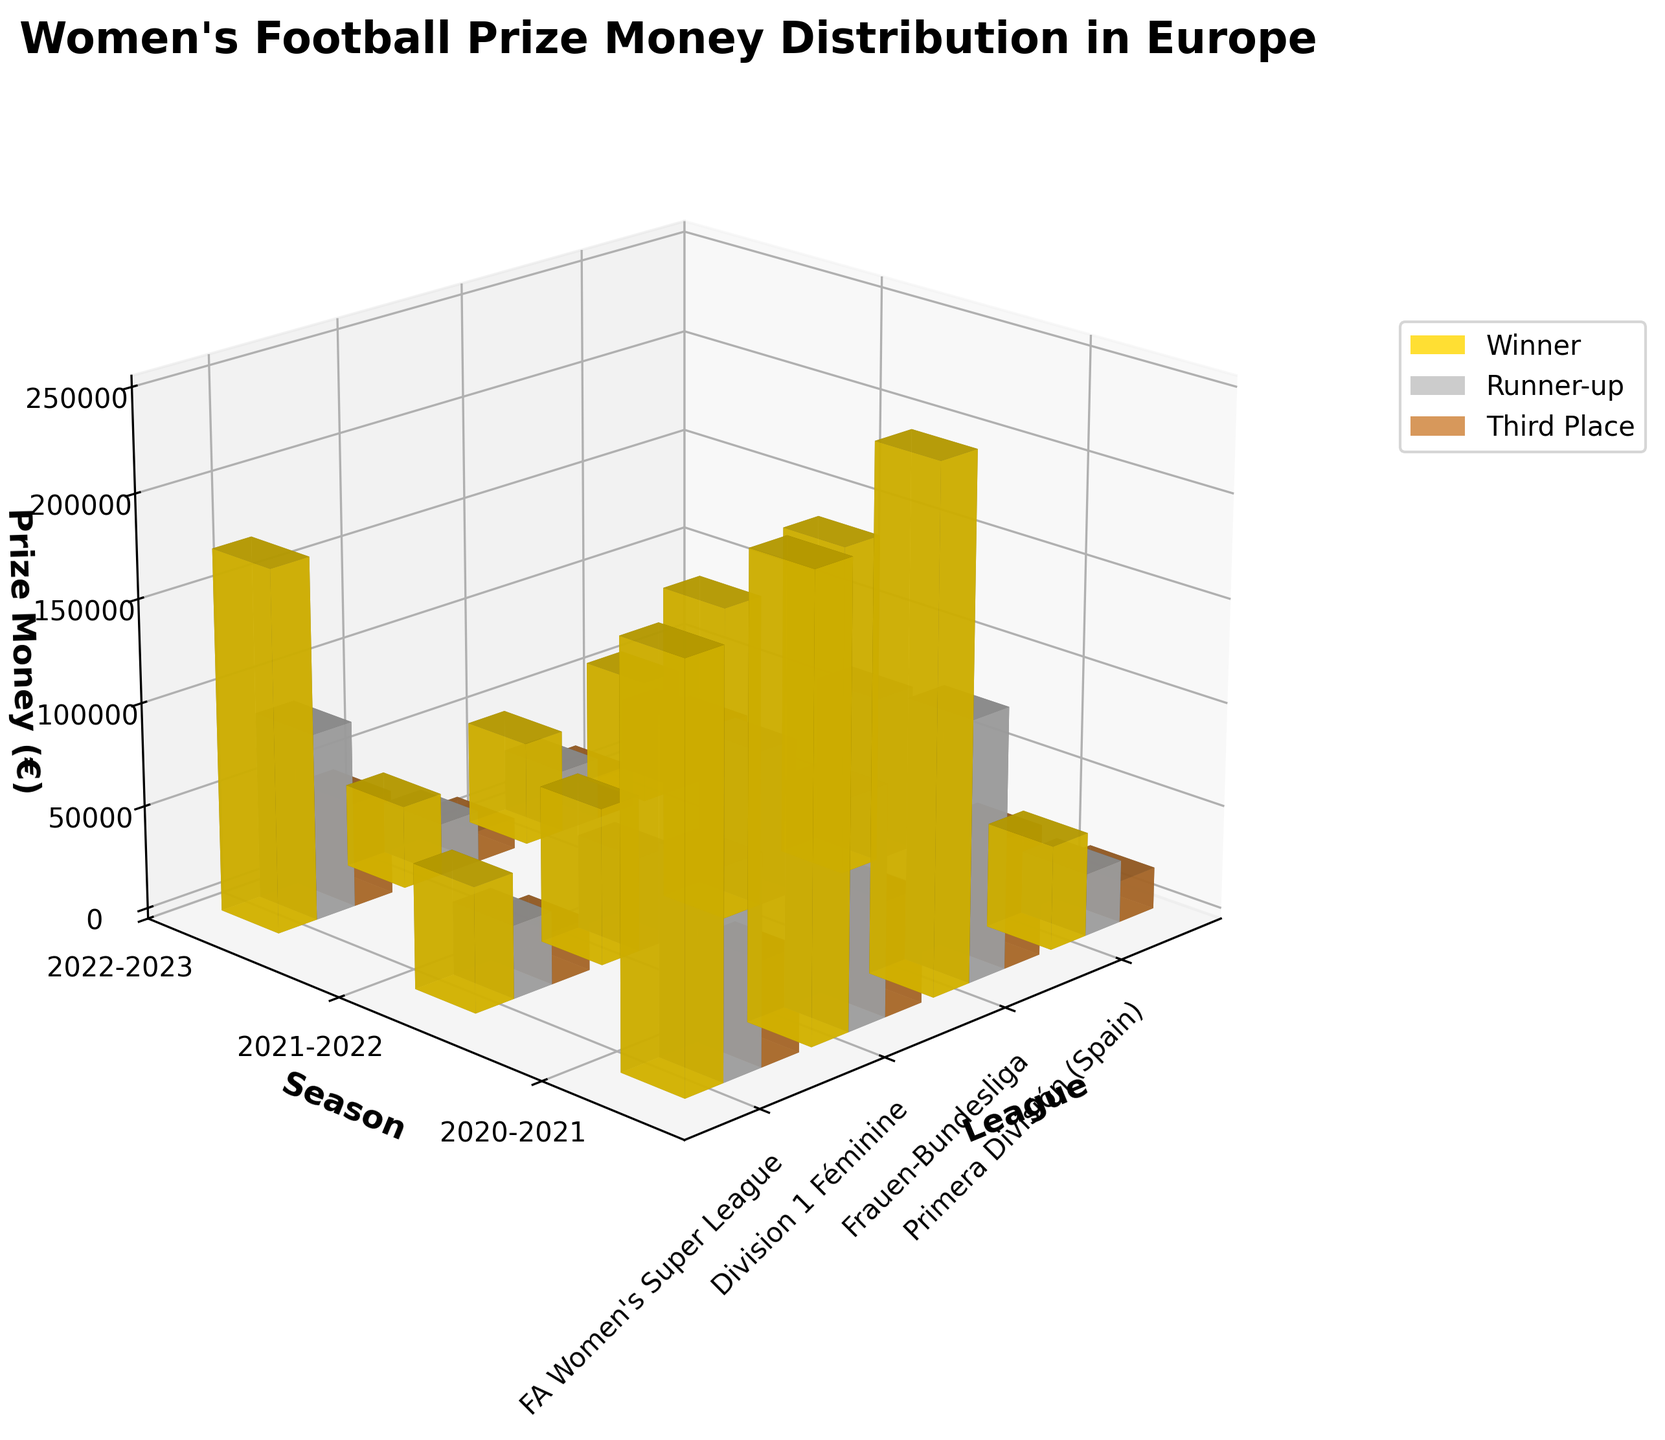What is the title of the figure? The title can be found at the top of the plot. It is a brief description of the plot's content.
Answer: Women's Football Prize Money Distribution in Europe Which league has the highest prize money for the winner in the 2022-2023 season? Look at the top bar levels for different leagues in the 2022-2023 season. The tallest yellow bar represents the highest prize money for the winner.
Answer: FA Women's Super League In the 2021-2022 season, what is the total prize money for the winner across all leagues? Summing the values for the winner prize (yellow bars) in 2021-2022 season across all leagues: 220000 + 60000 + 160000 + 50000.
Answer: 490000 How does the runner-up prize for Division 1 Féminine change from 2020-2021 to 2022-2023? Compare the height of the silver bars for Division 1 Féminine across the three seasons to see the differences: 30000 to 45000.
Answer: It increases by 15000 Which league had the least prize money for the third place in the 2020-2021 season? Find the shortest bronze bar in the 2020-2021 season.
Answer: Primera División (Spain) What is the difference in the winner prize between FA Women's Super League and Division 1 Féminine in the 2021-2022 season? Subtract the winner prize of Division 1 Féminine from that of FA Women's Super League for the 2021-2022 season (220000 - 60000).
Answer: 160000 In the 2022-2023 season, which has a higher prize money: the third-place prize in Frauen-Bundesliga or the runner-up prize in Primera División? Compare the height of the bronze bar for Frauen-Bundesliga and the silver bar for Primera División in the 2022-2023 season, 50000 and 35000.
Answer: Frauen-Bundesliga On average, how much does the runner-up prize increase each season for the FA Women's Super League? Calculate the total increase in the runner-up prize over three seasons and then divide by 2 (intervals): (110000 - 100000) + (125000 - 110000) = 25000, then 25000 / 2.
Answer: 12500 Which prize category shows the largest growth in the Primera División from 2021-2022 to 2022-2023? Compare the differences for each prize category (winner, runner-up, third place) between two seasons: 50000 to 60000, 30000 to 35000, 20000 to 25000 to find the largest change.
Answer: Winner Prize How does the total prize money for the top three positions in the Frauen-Bundesliga compare in 2020-2021 and 2022-2023? Sum the prize money for winner, runner-up, and third place in both years: 150000 + 75000 + 40000 = 265000 for 2020-2021; 175000 + 90000 + 50000 = 315000 for 2022-2023.
Answer: 50000 more in 2022-2023 